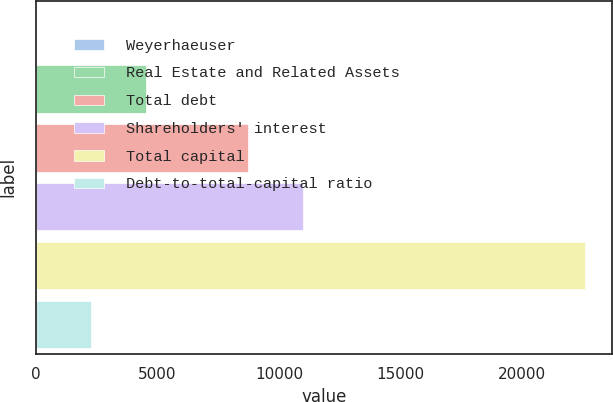<chart> <loc_0><loc_0><loc_500><loc_500><bar_chart><fcel>Weyerhaeuser<fcel>Real Estate and Related Assets<fcel>Total debt<fcel>Shareholders' interest<fcel>Total capital<fcel>Debt-to-total-capital ratio<nl><fcel>3<fcel>4517.2<fcel>8731<fcel>10988.1<fcel>22574<fcel>2260.1<nl></chart> 